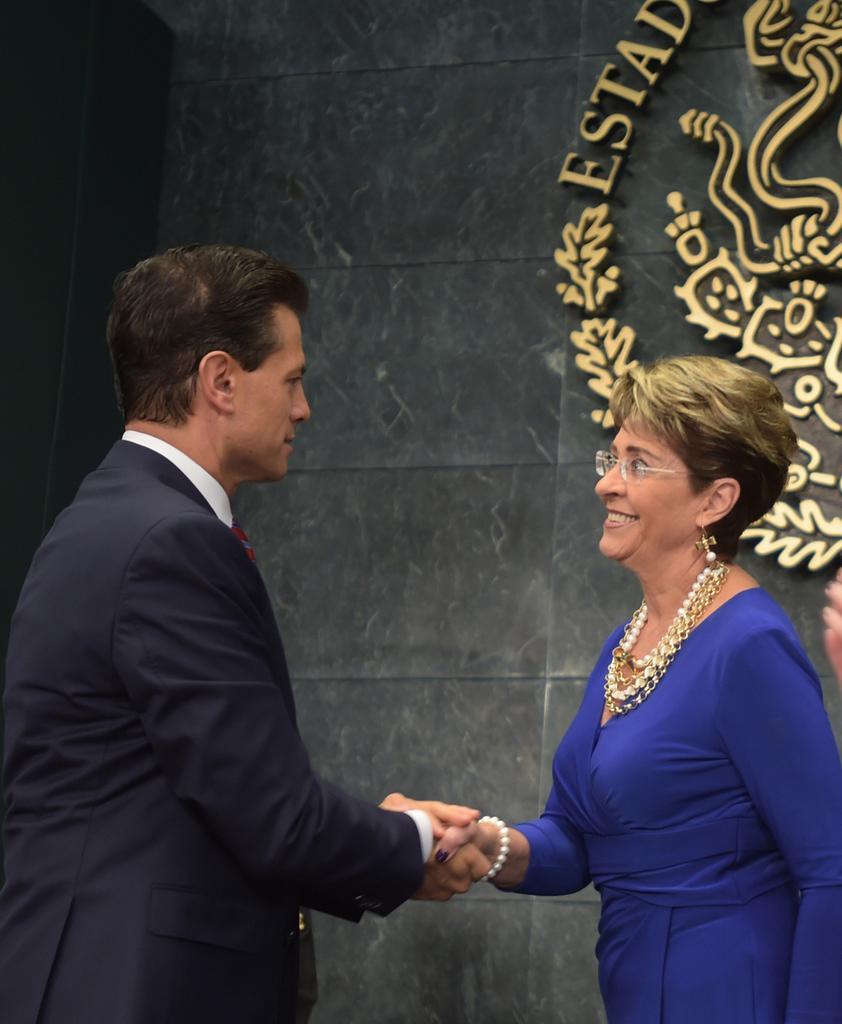In one or two sentences, can you explain what this image depicts? In this image there is a person wearing a blazer. He is holding the hand of a woman. She is wearing a blue dress and spectacles. Background there is a wall having some text and few images. Right side a person's hand is visible. 